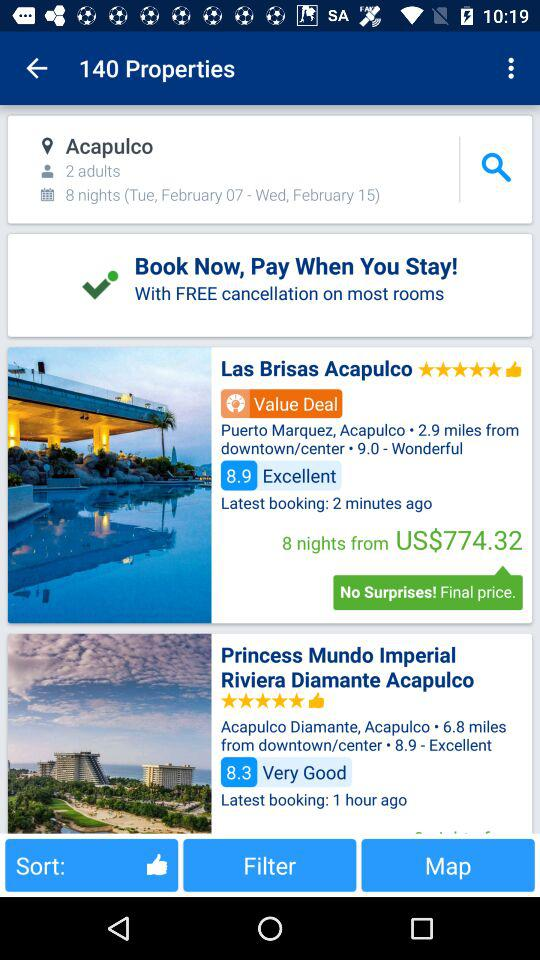How much is the distance of the "Las Brisas Acapulco" property from downtown/center? The distance of the "Las Brisas Acapulco" property from downtown/center is 2.9 miles. 